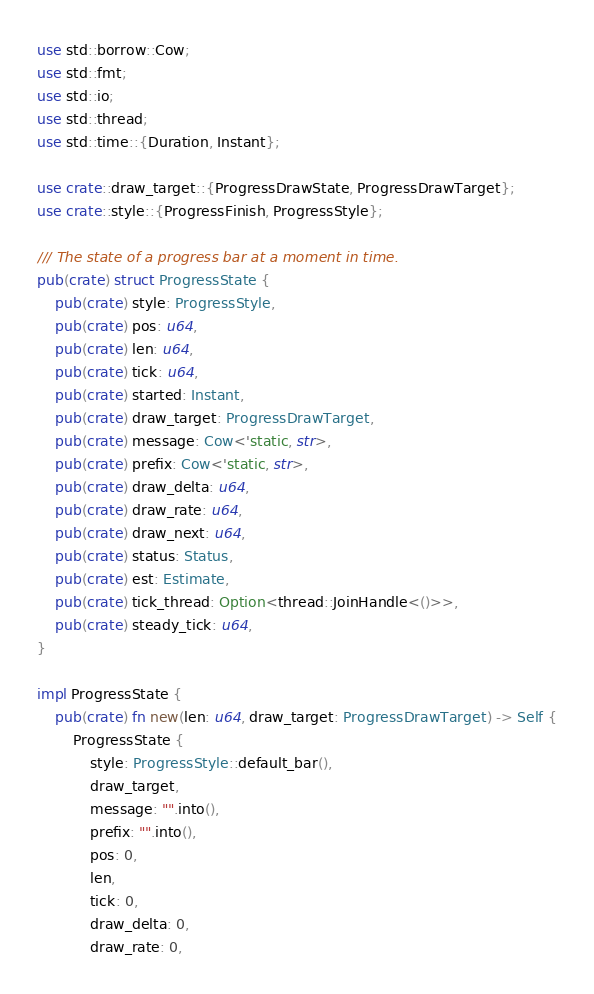Convert code to text. <code><loc_0><loc_0><loc_500><loc_500><_Rust_>use std::borrow::Cow;
use std::fmt;
use std::io;
use std::thread;
use std::time::{Duration, Instant};

use crate::draw_target::{ProgressDrawState, ProgressDrawTarget};
use crate::style::{ProgressFinish, ProgressStyle};

/// The state of a progress bar at a moment in time.
pub(crate) struct ProgressState {
    pub(crate) style: ProgressStyle,
    pub(crate) pos: u64,
    pub(crate) len: u64,
    pub(crate) tick: u64,
    pub(crate) started: Instant,
    pub(crate) draw_target: ProgressDrawTarget,
    pub(crate) message: Cow<'static, str>,
    pub(crate) prefix: Cow<'static, str>,
    pub(crate) draw_delta: u64,
    pub(crate) draw_rate: u64,
    pub(crate) draw_next: u64,
    pub(crate) status: Status,
    pub(crate) est: Estimate,
    pub(crate) tick_thread: Option<thread::JoinHandle<()>>,
    pub(crate) steady_tick: u64,
}

impl ProgressState {
    pub(crate) fn new(len: u64, draw_target: ProgressDrawTarget) -> Self {
        ProgressState {
            style: ProgressStyle::default_bar(),
            draw_target,
            message: "".into(),
            prefix: "".into(),
            pos: 0,
            len,
            tick: 0,
            draw_delta: 0,
            draw_rate: 0,</code> 